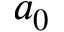<formula> <loc_0><loc_0><loc_500><loc_500>a _ { 0 }</formula> 